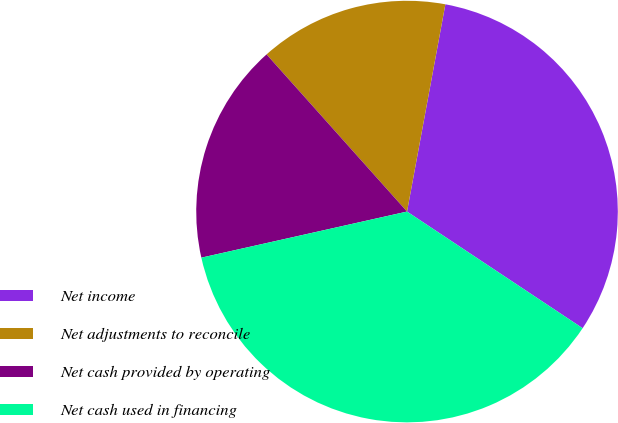<chart> <loc_0><loc_0><loc_500><loc_500><pie_chart><fcel>Net income<fcel>Net adjustments to reconcile<fcel>Net cash provided by operating<fcel>Net cash used in financing<nl><fcel>31.42%<fcel>14.52%<fcel>16.9%<fcel>37.16%<nl></chart> 